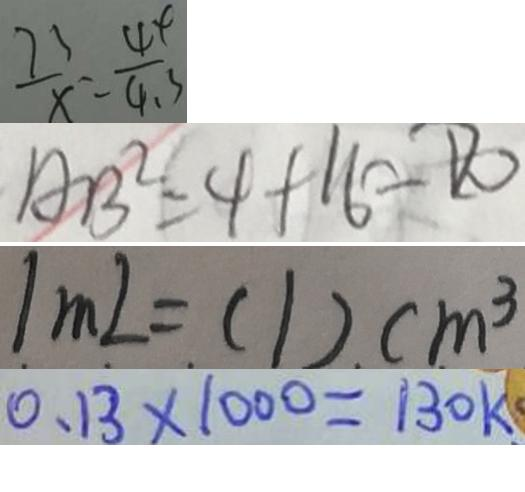Convert formula to latex. <formula><loc_0><loc_0><loc_500><loc_500>\frac { 7 3 } { x } = \frac { 4 4 } { 4 . 3 } 
 A B ^ { 2 } = 4 + 1 6 = D 0 
 1 m L = ( 1 ) c m ^ { 3 } 
 0 . 1 3 \times 1 0 0 0 = 1 3 0 k</formula> 